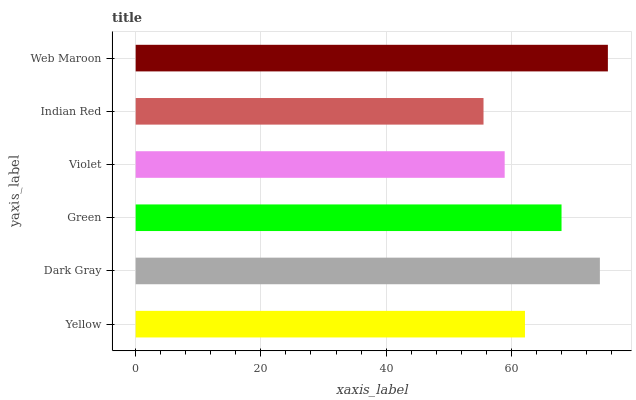Is Indian Red the minimum?
Answer yes or no. Yes. Is Web Maroon the maximum?
Answer yes or no. Yes. Is Dark Gray the minimum?
Answer yes or no. No. Is Dark Gray the maximum?
Answer yes or no. No. Is Dark Gray greater than Yellow?
Answer yes or no. Yes. Is Yellow less than Dark Gray?
Answer yes or no. Yes. Is Yellow greater than Dark Gray?
Answer yes or no. No. Is Dark Gray less than Yellow?
Answer yes or no. No. Is Green the high median?
Answer yes or no. Yes. Is Yellow the low median?
Answer yes or no. Yes. Is Indian Red the high median?
Answer yes or no. No. Is Indian Red the low median?
Answer yes or no. No. 